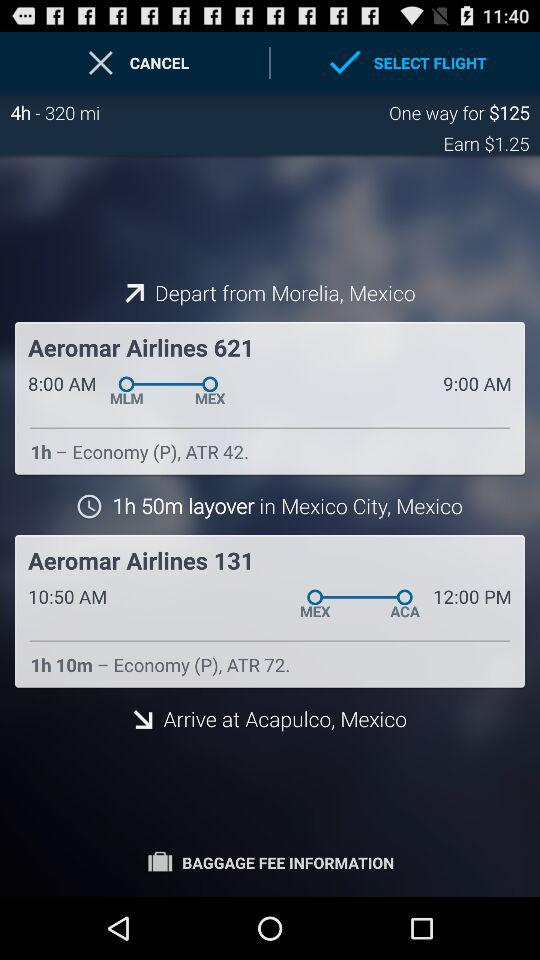What is the arrival time of the Aeromar Airlines 621 flight? The arrival time of the Aeromar Airlines 621 flight is 9:00 AM. 